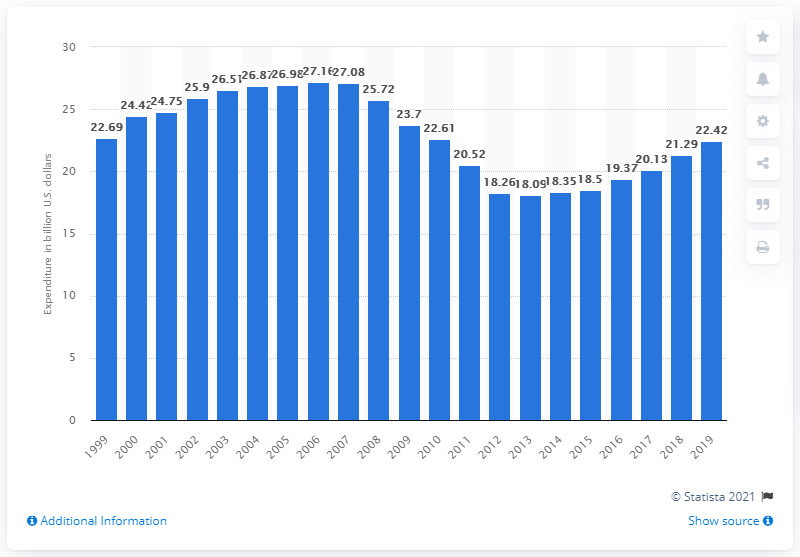Can you describe the trend in consumer expenditure on recreational books over the past two decades based on the image? The bar chart shows fluctuations in consumer expenditure on recreational books in the US from 1999 to 2019. The initial decade displays a consistent increase, peaking in 2009. Following that, there's a period of decline until around 2013, and then the numbers plateau with slight variations in the subsequent years. 